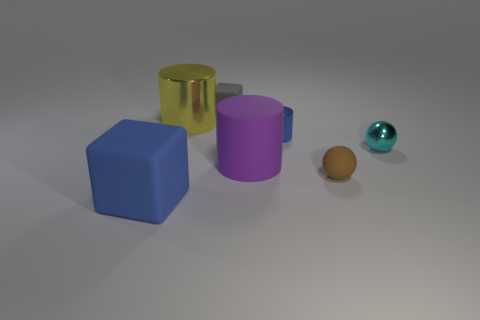Add 3 big cylinders. How many objects exist? 10 Subtract all cylinders. How many objects are left? 4 Add 3 small cubes. How many small cubes exist? 4 Subtract 1 blue cylinders. How many objects are left? 6 Subtract all matte spheres. Subtract all purple rubber objects. How many objects are left? 5 Add 3 big objects. How many big objects are left? 6 